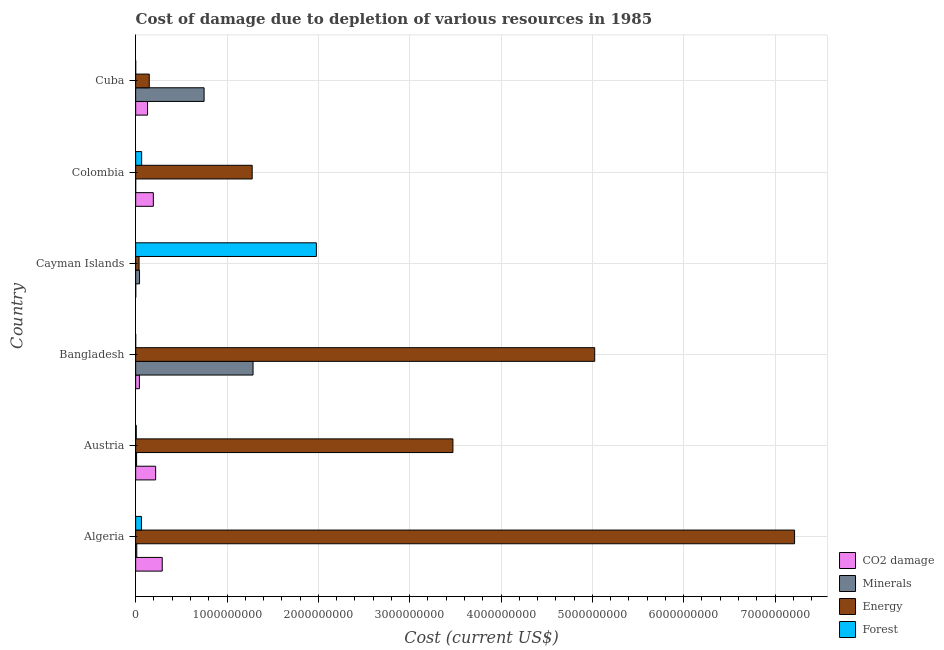Are the number of bars on each tick of the Y-axis equal?
Provide a succinct answer. Yes. How many bars are there on the 6th tick from the top?
Your response must be concise. 4. How many bars are there on the 4th tick from the bottom?
Provide a short and direct response. 4. What is the label of the 2nd group of bars from the top?
Your response must be concise. Colombia. What is the cost of damage due to depletion of coal in Cuba?
Make the answer very short. 1.30e+08. Across all countries, what is the maximum cost of damage due to depletion of coal?
Provide a short and direct response. 2.91e+08. Across all countries, what is the minimum cost of damage due to depletion of energy?
Keep it short and to the point. 3.70e+07. In which country was the cost of damage due to depletion of coal maximum?
Keep it short and to the point. Algeria. In which country was the cost of damage due to depletion of energy minimum?
Ensure brevity in your answer.  Cayman Islands. What is the total cost of damage due to depletion of forests in the graph?
Make the answer very short. 2.11e+09. What is the difference between the cost of damage due to depletion of minerals in Austria and that in Bangladesh?
Offer a terse response. -1.27e+09. What is the difference between the cost of damage due to depletion of forests in Bangladesh and the cost of damage due to depletion of coal in Cuba?
Give a very brief answer. -1.30e+08. What is the average cost of damage due to depletion of energy per country?
Ensure brevity in your answer.  2.86e+09. What is the difference between the cost of damage due to depletion of coal and cost of damage due to depletion of energy in Algeria?
Your answer should be very brief. -6.92e+09. In how many countries, is the cost of damage due to depletion of minerals greater than 5200000000 US$?
Give a very brief answer. 0. What is the ratio of the cost of damage due to depletion of forests in Algeria to that in Cayman Islands?
Give a very brief answer. 0.03. Is the cost of damage due to depletion of energy in Bangladesh less than that in Cayman Islands?
Keep it short and to the point. No. Is the difference between the cost of damage due to depletion of forests in Algeria and Cuba greater than the difference between the cost of damage due to depletion of coal in Algeria and Cuba?
Keep it short and to the point. No. What is the difference between the highest and the second highest cost of damage due to depletion of coal?
Provide a short and direct response. 7.23e+07. What is the difference between the highest and the lowest cost of damage due to depletion of forests?
Offer a terse response. 1.98e+09. In how many countries, is the cost of damage due to depletion of forests greater than the average cost of damage due to depletion of forests taken over all countries?
Offer a terse response. 1. Is it the case that in every country, the sum of the cost of damage due to depletion of coal and cost of damage due to depletion of forests is greater than the sum of cost of damage due to depletion of minerals and cost of damage due to depletion of energy?
Your response must be concise. No. What does the 4th bar from the top in Bangladesh represents?
Ensure brevity in your answer.  CO2 damage. What does the 2nd bar from the bottom in Cuba represents?
Ensure brevity in your answer.  Minerals. How many bars are there?
Your response must be concise. 24. Are all the bars in the graph horizontal?
Provide a short and direct response. Yes. How many countries are there in the graph?
Offer a terse response. 6. Does the graph contain any zero values?
Offer a very short reply. No. Does the graph contain grids?
Your response must be concise. Yes. Where does the legend appear in the graph?
Your answer should be compact. Bottom right. How many legend labels are there?
Provide a short and direct response. 4. What is the title of the graph?
Keep it short and to the point. Cost of damage due to depletion of various resources in 1985 . Does "Fiscal policy" appear as one of the legend labels in the graph?
Your answer should be compact. No. What is the label or title of the X-axis?
Your response must be concise. Cost (current US$). What is the label or title of the Y-axis?
Your answer should be compact. Country. What is the Cost (current US$) of CO2 damage in Algeria?
Your answer should be compact. 2.91e+08. What is the Cost (current US$) of Minerals in Algeria?
Your answer should be very brief. 1.20e+07. What is the Cost (current US$) in Energy in Algeria?
Provide a succinct answer. 7.21e+09. What is the Cost (current US$) in Forest in Algeria?
Make the answer very short. 6.32e+07. What is the Cost (current US$) of CO2 damage in Austria?
Give a very brief answer. 2.19e+08. What is the Cost (current US$) of Minerals in Austria?
Provide a short and direct response. 1.01e+07. What is the Cost (current US$) in Energy in Austria?
Offer a very short reply. 3.47e+09. What is the Cost (current US$) in Forest in Austria?
Provide a short and direct response. 6.24e+06. What is the Cost (current US$) in CO2 damage in Bangladesh?
Ensure brevity in your answer.  4.09e+07. What is the Cost (current US$) in Minerals in Bangladesh?
Keep it short and to the point. 1.29e+09. What is the Cost (current US$) of Energy in Bangladesh?
Your answer should be compact. 5.03e+09. What is the Cost (current US$) in Forest in Bangladesh?
Your answer should be compact. 6.86e+04. What is the Cost (current US$) in CO2 damage in Cayman Islands?
Give a very brief answer. 7.77e+05. What is the Cost (current US$) of Minerals in Cayman Islands?
Provide a succinct answer. 4.23e+07. What is the Cost (current US$) of Energy in Cayman Islands?
Offer a very short reply. 3.70e+07. What is the Cost (current US$) of Forest in Cayman Islands?
Your answer should be very brief. 1.98e+09. What is the Cost (current US$) of CO2 damage in Colombia?
Give a very brief answer. 1.93e+08. What is the Cost (current US$) in Minerals in Colombia?
Your answer should be compact. 9103.63. What is the Cost (current US$) of Energy in Colombia?
Offer a very short reply. 1.28e+09. What is the Cost (current US$) in Forest in Colombia?
Provide a succinct answer. 6.54e+07. What is the Cost (current US$) in CO2 damage in Cuba?
Give a very brief answer. 1.30e+08. What is the Cost (current US$) in Minerals in Cuba?
Make the answer very short. 7.49e+08. What is the Cost (current US$) in Energy in Cuba?
Your answer should be very brief. 1.49e+08. What is the Cost (current US$) of Forest in Cuba?
Your answer should be compact. 6.25e+04. Across all countries, what is the maximum Cost (current US$) in CO2 damage?
Provide a succinct answer. 2.91e+08. Across all countries, what is the maximum Cost (current US$) of Minerals?
Offer a very short reply. 1.29e+09. Across all countries, what is the maximum Cost (current US$) of Energy?
Ensure brevity in your answer.  7.21e+09. Across all countries, what is the maximum Cost (current US$) of Forest?
Provide a succinct answer. 1.98e+09. Across all countries, what is the minimum Cost (current US$) in CO2 damage?
Your answer should be very brief. 7.77e+05. Across all countries, what is the minimum Cost (current US$) in Minerals?
Your response must be concise. 9103.63. Across all countries, what is the minimum Cost (current US$) in Energy?
Offer a terse response. 3.70e+07. Across all countries, what is the minimum Cost (current US$) of Forest?
Provide a short and direct response. 6.25e+04. What is the total Cost (current US$) of CO2 damage in the graph?
Ensure brevity in your answer.  8.75e+08. What is the total Cost (current US$) of Minerals in the graph?
Offer a very short reply. 2.10e+09. What is the total Cost (current US$) of Energy in the graph?
Offer a very short reply. 1.72e+1. What is the total Cost (current US$) of Forest in the graph?
Offer a very short reply. 2.11e+09. What is the difference between the Cost (current US$) of CO2 damage in Algeria and that in Austria?
Your answer should be very brief. 7.23e+07. What is the difference between the Cost (current US$) in Minerals in Algeria and that in Austria?
Offer a terse response. 1.90e+06. What is the difference between the Cost (current US$) in Energy in Algeria and that in Austria?
Your answer should be compact. 3.74e+09. What is the difference between the Cost (current US$) in Forest in Algeria and that in Austria?
Offer a very short reply. 5.70e+07. What is the difference between the Cost (current US$) of CO2 damage in Algeria and that in Bangladesh?
Your answer should be compact. 2.50e+08. What is the difference between the Cost (current US$) of Minerals in Algeria and that in Bangladesh?
Your answer should be compact. -1.27e+09. What is the difference between the Cost (current US$) in Energy in Algeria and that in Bangladesh?
Offer a very short reply. 2.19e+09. What is the difference between the Cost (current US$) in Forest in Algeria and that in Bangladesh?
Give a very brief answer. 6.32e+07. What is the difference between the Cost (current US$) in CO2 damage in Algeria and that in Cayman Islands?
Your answer should be very brief. 2.90e+08. What is the difference between the Cost (current US$) in Minerals in Algeria and that in Cayman Islands?
Provide a short and direct response. -3.03e+07. What is the difference between the Cost (current US$) in Energy in Algeria and that in Cayman Islands?
Your answer should be very brief. 7.18e+09. What is the difference between the Cost (current US$) in Forest in Algeria and that in Cayman Islands?
Your response must be concise. -1.92e+09. What is the difference between the Cost (current US$) of CO2 damage in Algeria and that in Colombia?
Your answer should be compact. 9.75e+07. What is the difference between the Cost (current US$) of Minerals in Algeria and that in Colombia?
Your answer should be very brief. 1.20e+07. What is the difference between the Cost (current US$) in Energy in Algeria and that in Colombia?
Provide a succinct answer. 5.94e+09. What is the difference between the Cost (current US$) of Forest in Algeria and that in Colombia?
Provide a short and direct response. -2.21e+06. What is the difference between the Cost (current US$) in CO2 damage in Algeria and that in Cuba?
Your answer should be very brief. 1.61e+08. What is the difference between the Cost (current US$) of Minerals in Algeria and that in Cuba?
Offer a terse response. -7.37e+08. What is the difference between the Cost (current US$) of Energy in Algeria and that in Cuba?
Offer a very short reply. 7.07e+09. What is the difference between the Cost (current US$) in Forest in Algeria and that in Cuba?
Give a very brief answer. 6.32e+07. What is the difference between the Cost (current US$) of CO2 damage in Austria and that in Bangladesh?
Keep it short and to the point. 1.78e+08. What is the difference between the Cost (current US$) in Minerals in Austria and that in Bangladesh?
Keep it short and to the point. -1.27e+09. What is the difference between the Cost (current US$) in Energy in Austria and that in Bangladesh?
Give a very brief answer. -1.55e+09. What is the difference between the Cost (current US$) in Forest in Austria and that in Bangladesh?
Your answer should be compact. 6.17e+06. What is the difference between the Cost (current US$) of CO2 damage in Austria and that in Cayman Islands?
Offer a very short reply. 2.18e+08. What is the difference between the Cost (current US$) in Minerals in Austria and that in Cayman Islands?
Make the answer very short. -3.22e+07. What is the difference between the Cost (current US$) in Energy in Austria and that in Cayman Islands?
Your answer should be compact. 3.44e+09. What is the difference between the Cost (current US$) in Forest in Austria and that in Cayman Islands?
Provide a succinct answer. -1.97e+09. What is the difference between the Cost (current US$) of CO2 damage in Austria and that in Colombia?
Your response must be concise. 2.53e+07. What is the difference between the Cost (current US$) of Minerals in Austria and that in Colombia?
Ensure brevity in your answer.  1.01e+07. What is the difference between the Cost (current US$) in Energy in Austria and that in Colombia?
Offer a very short reply. 2.20e+09. What is the difference between the Cost (current US$) of Forest in Austria and that in Colombia?
Provide a short and direct response. -5.92e+07. What is the difference between the Cost (current US$) of CO2 damage in Austria and that in Cuba?
Give a very brief answer. 8.84e+07. What is the difference between the Cost (current US$) of Minerals in Austria and that in Cuba?
Give a very brief answer. -7.39e+08. What is the difference between the Cost (current US$) in Energy in Austria and that in Cuba?
Your answer should be very brief. 3.32e+09. What is the difference between the Cost (current US$) of Forest in Austria and that in Cuba?
Offer a very short reply. 6.18e+06. What is the difference between the Cost (current US$) of CO2 damage in Bangladesh and that in Cayman Islands?
Your response must be concise. 4.01e+07. What is the difference between the Cost (current US$) in Minerals in Bangladesh and that in Cayman Islands?
Your answer should be compact. 1.24e+09. What is the difference between the Cost (current US$) of Energy in Bangladesh and that in Cayman Islands?
Make the answer very short. 4.99e+09. What is the difference between the Cost (current US$) of Forest in Bangladesh and that in Cayman Islands?
Ensure brevity in your answer.  -1.98e+09. What is the difference between the Cost (current US$) of CO2 damage in Bangladesh and that in Colombia?
Your response must be concise. -1.52e+08. What is the difference between the Cost (current US$) of Minerals in Bangladesh and that in Colombia?
Your answer should be very brief. 1.29e+09. What is the difference between the Cost (current US$) in Energy in Bangladesh and that in Colombia?
Make the answer very short. 3.75e+09. What is the difference between the Cost (current US$) of Forest in Bangladesh and that in Colombia?
Provide a succinct answer. -6.54e+07. What is the difference between the Cost (current US$) of CO2 damage in Bangladesh and that in Cuba?
Keep it short and to the point. -8.93e+07. What is the difference between the Cost (current US$) in Minerals in Bangladesh and that in Cuba?
Provide a succinct answer. 5.36e+08. What is the difference between the Cost (current US$) in Energy in Bangladesh and that in Cuba?
Keep it short and to the point. 4.88e+09. What is the difference between the Cost (current US$) in Forest in Bangladesh and that in Cuba?
Your answer should be very brief. 6110.87. What is the difference between the Cost (current US$) in CO2 damage in Cayman Islands and that in Colombia?
Give a very brief answer. -1.93e+08. What is the difference between the Cost (current US$) of Minerals in Cayman Islands and that in Colombia?
Your answer should be compact. 4.23e+07. What is the difference between the Cost (current US$) of Energy in Cayman Islands and that in Colombia?
Your answer should be very brief. -1.24e+09. What is the difference between the Cost (current US$) in Forest in Cayman Islands and that in Colombia?
Provide a short and direct response. 1.91e+09. What is the difference between the Cost (current US$) of CO2 damage in Cayman Islands and that in Cuba?
Make the answer very short. -1.29e+08. What is the difference between the Cost (current US$) in Minerals in Cayman Islands and that in Cuba?
Ensure brevity in your answer.  -7.07e+08. What is the difference between the Cost (current US$) of Energy in Cayman Islands and that in Cuba?
Your response must be concise. -1.12e+08. What is the difference between the Cost (current US$) in Forest in Cayman Islands and that in Cuba?
Keep it short and to the point. 1.98e+09. What is the difference between the Cost (current US$) in CO2 damage in Colombia and that in Cuba?
Ensure brevity in your answer.  6.31e+07. What is the difference between the Cost (current US$) in Minerals in Colombia and that in Cuba?
Provide a short and direct response. -7.49e+08. What is the difference between the Cost (current US$) of Energy in Colombia and that in Cuba?
Offer a terse response. 1.13e+09. What is the difference between the Cost (current US$) of Forest in Colombia and that in Cuba?
Give a very brief answer. 6.54e+07. What is the difference between the Cost (current US$) in CO2 damage in Algeria and the Cost (current US$) in Minerals in Austria?
Offer a very short reply. 2.81e+08. What is the difference between the Cost (current US$) in CO2 damage in Algeria and the Cost (current US$) in Energy in Austria?
Give a very brief answer. -3.18e+09. What is the difference between the Cost (current US$) of CO2 damage in Algeria and the Cost (current US$) of Forest in Austria?
Offer a terse response. 2.85e+08. What is the difference between the Cost (current US$) of Minerals in Algeria and the Cost (current US$) of Energy in Austria?
Ensure brevity in your answer.  -3.46e+09. What is the difference between the Cost (current US$) of Minerals in Algeria and the Cost (current US$) of Forest in Austria?
Make the answer very short. 5.74e+06. What is the difference between the Cost (current US$) of Energy in Algeria and the Cost (current US$) of Forest in Austria?
Provide a succinct answer. 7.21e+09. What is the difference between the Cost (current US$) in CO2 damage in Algeria and the Cost (current US$) in Minerals in Bangladesh?
Offer a terse response. -9.94e+08. What is the difference between the Cost (current US$) in CO2 damage in Algeria and the Cost (current US$) in Energy in Bangladesh?
Offer a terse response. -4.73e+09. What is the difference between the Cost (current US$) of CO2 damage in Algeria and the Cost (current US$) of Forest in Bangladesh?
Provide a succinct answer. 2.91e+08. What is the difference between the Cost (current US$) in Minerals in Algeria and the Cost (current US$) in Energy in Bangladesh?
Give a very brief answer. -5.01e+09. What is the difference between the Cost (current US$) of Minerals in Algeria and the Cost (current US$) of Forest in Bangladesh?
Your answer should be compact. 1.19e+07. What is the difference between the Cost (current US$) of Energy in Algeria and the Cost (current US$) of Forest in Bangladesh?
Your answer should be compact. 7.21e+09. What is the difference between the Cost (current US$) in CO2 damage in Algeria and the Cost (current US$) in Minerals in Cayman Islands?
Offer a terse response. 2.49e+08. What is the difference between the Cost (current US$) of CO2 damage in Algeria and the Cost (current US$) of Energy in Cayman Islands?
Your answer should be compact. 2.54e+08. What is the difference between the Cost (current US$) in CO2 damage in Algeria and the Cost (current US$) in Forest in Cayman Islands?
Give a very brief answer. -1.69e+09. What is the difference between the Cost (current US$) of Minerals in Algeria and the Cost (current US$) of Energy in Cayman Islands?
Make the answer very short. -2.51e+07. What is the difference between the Cost (current US$) in Minerals in Algeria and the Cost (current US$) in Forest in Cayman Islands?
Give a very brief answer. -1.97e+09. What is the difference between the Cost (current US$) in Energy in Algeria and the Cost (current US$) in Forest in Cayman Islands?
Keep it short and to the point. 5.24e+09. What is the difference between the Cost (current US$) in CO2 damage in Algeria and the Cost (current US$) in Minerals in Colombia?
Your answer should be compact. 2.91e+08. What is the difference between the Cost (current US$) in CO2 damage in Algeria and the Cost (current US$) in Energy in Colombia?
Provide a short and direct response. -9.85e+08. What is the difference between the Cost (current US$) of CO2 damage in Algeria and the Cost (current US$) of Forest in Colombia?
Your answer should be very brief. 2.25e+08. What is the difference between the Cost (current US$) of Minerals in Algeria and the Cost (current US$) of Energy in Colombia?
Ensure brevity in your answer.  -1.26e+09. What is the difference between the Cost (current US$) in Minerals in Algeria and the Cost (current US$) in Forest in Colombia?
Offer a very short reply. -5.35e+07. What is the difference between the Cost (current US$) in Energy in Algeria and the Cost (current US$) in Forest in Colombia?
Keep it short and to the point. 7.15e+09. What is the difference between the Cost (current US$) of CO2 damage in Algeria and the Cost (current US$) of Minerals in Cuba?
Keep it short and to the point. -4.58e+08. What is the difference between the Cost (current US$) in CO2 damage in Algeria and the Cost (current US$) in Energy in Cuba?
Provide a short and direct response. 1.42e+08. What is the difference between the Cost (current US$) of CO2 damage in Algeria and the Cost (current US$) of Forest in Cuba?
Give a very brief answer. 2.91e+08. What is the difference between the Cost (current US$) of Minerals in Algeria and the Cost (current US$) of Energy in Cuba?
Make the answer very short. -1.37e+08. What is the difference between the Cost (current US$) of Minerals in Algeria and the Cost (current US$) of Forest in Cuba?
Make the answer very short. 1.19e+07. What is the difference between the Cost (current US$) of Energy in Algeria and the Cost (current US$) of Forest in Cuba?
Ensure brevity in your answer.  7.21e+09. What is the difference between the Cost (current US$) in CO2 damage in Austria and the Cost (current US$) in Minerals in Bangladesh?
Your answer should be compact. -1.07e+09. What is the difference between the Cost (current US$) of CO2 damage in Austria and the Cost (current US$) of Energy in Bangladesh?
Your answer should be very brief. -4.81e+09. What is the difference between the Cost (current US$) of CO2 damage in Austria and the Cost (current US$) of Forest in Bangladesh?
Make the answer very short. 2.18e+08. What is the difference between the Cost (current US$) of Minerals in Austria and the Cost (current US$) of Energy in Bangladesh?
Your answer should be very brief. -5.02e+09. What is the difference between the Cost (current US$) of Minerals in Austria and the Cost (current US$) of Forest in Bangladesh?
Ensure brevity in your answer.  1.00e+07. What is the difference between the Cost (current US$) of Energy in Austria and the Cost (current US$) of Forest in Bangladesh?
Offer a very short reply. 3.47e+09. What is the difference between the Cost (current US$) in CO2 damage in Austria and the Cost (current US$) in Minerals in Cayman Islands?
Your answer should be compact. 1.76e+08. What is the difference between the Cost (current US$) of CO2 damage in Austria and the Cost (current US$) of Energy in Cayman Islands?
Ensure brevity in your answer.  1.82e+08. What is the difference between the Cost (current US$) of CO2 damage in Austria and the Cost (current US$) of Forest in Cayman Islands?
Your answer should be compact. -1.76e+09. What is the difference between the Cost (current US$) in Minerals in Austria and the Cost (current US$) in Energy in Cayman Islands?
Make the answer very short. -2.70e+07. What is the difference between the Cost (current US$) in Minerals in Austria and the Cost (current US$) in Forest in Cayman Islands?
Keep it short and to the point. -1.97e+09. What is the difference between the Cost (current US$) of Energy in Austria and the Cost (current US$) of Forest in Cayman Islands?
Your answer should be compact. 1.49e+09. What is the difference between the Cost (current US$) of CO2 damage in Austria and the Cost (current US$) of Minerals in Colombia?
Give a very brief answer. 2.19e+08. What is the difference between the Cost (current US$) of CO2 damage in Austria and the Cost (current US$) of Energy in Colombia?
Offer a terse response. -1.06e+09. What is the difference between the Cost (current US$) in CO2 damage in Austria and the Cost (current US$) in Forest in Colombia?
Your answer should be very brief. 1.53e+08. What is the difference between the Cost (current US$) in Minerals in Austria and the Cost (current US$) in Energy in Colombia?
Give a very brief answer. -1.27e+09. What is the difference between the Cost (current US$) of Minerals in Austria and the Cost (current US$) of Forest in Colombia?
Keep it short and to the point. -5.54e+07. What is the difference between the Cost (current US$) in Energy in Austria and the Cost (current US$) in Forest in Colombia?
Offer a terse response. 3.41e+09. What is the difference between the Cost (current US$) in CO2 damage in Austria and the Cost (current US$) in Minerals in Cuba?
Offer a terse response. -5.31e+08. What is the difference between the Cost (current US$) in CO2 damage in Austria and the Cost (current US$) in Energy in Cuba?
Ensure brevity in your answer.  6.97e+07. What is the difference between the Cost (current US$) of CO2 damage in Austria and the Cost (current US$) of Forest in Cuba?
Your response must be concise. 2.18e+08. What is the difference between the Cost (current US$) of Minerals in Austria and the Cost (current US$) of Energy in Cuba?
Give a very brief answer. -1.39e+08. What is the difference between the Cost (current US$) of Minerals in Austria and the Cost (current US$) of Forest in Cuba?
Your answer should be very brief. 1.00e+07. What is the difference between the Cost (current US$) of Energy in Austria and the Cost (current US$) of Forest in Cuba?
Your answer should be very brief. 3.47e+09. What is the difference between the Cost (current US$) in CO2 damage in Bangladesh and the Cost (current US$) in Minerals in Cayman Islands?
Provide a succinct answer. -1.40e+06. What is the difference between the Cost (current US$) in CO2 damage in Bangladesh and the Cost (current US$) in Energy in Cayman Islands?
Provide a short and direct response. 3.86e+06. What is the difference between the Cost (current US$) in CO2 damage in Bangladesh and the Cost (current US$) in Forest in Cayman Islands?
Keep it short and to the point. -1.94e+09. What is the difference between the Cost (current US$) in Minerals in Bangladesh and the Cost (current US$) in Energy in Cayman Islands?
Keep it short and to the point. 1.25e+09. What is the difference between the Cost (current US$) of Minerals in Bangladesh and the Cost (current US$) of Forest in Cayman Islands?
Provide a succinct answer. -6.93e+08. What is the difference between the Cost (current US$) of Energy in Bangladesh and the Cost (current US$) of Forest in Cayman Islands?
Make the answer very short. 3.05e+09. What is the difference between the Cost (current US$) of CO2 damage in Bangladesh and the Cost (current US$) of Minerals in Colombia?
Keep it short and to the point. 4.09e+07. What is the difference between the Cost (current US$) of CO2 damage in Bangladesh and the Cost (current US$) of Energy in Colombia?
Make the answer very short. -1.23e+09. What is the difference between the Cost (current US$) of CO2 damage in Bangladesh and the Cost (current US$) of Forest in Colombia?
Keep it short and to the point. -2.45e+07. What is the difference between the Cost (current US$) of Minerals in Bangladesh and the Cost (current US$) of Energy in Colombia?
Offer a terse response. 9.38e+06. What is the difference between the Cost (current US$) of Minerals in Bangladesh and the Cost (current US$) of Forest in Colombia?
Provide a succinct answer. 1.22e+09. What is the difference between the Cost (current US$) of Energy in Bangladesh and the Cost (current US$) of Forest in Colombia?
Your answer should be compact. 4.96e+09. What is the difference between the Cost (current US$) in CO2 damage in Bangladesh and the Cost (current US$) in Minerals in Cuba?
Provide a short and direct response. -7.08e+08. What is the difference between the Cost (current US$) of CO2 damage in Bangladesh and the Cost (current US$) of Energy in Cuba?
Provide a succinct answer. -1.08e+08. What is the difference between the Cost (current US$) in CO2 damage in Bangladesh and the Cost (current US$) in Forest in Cuba?
Your answer should be compact. 4.08e+07. What is the difference between the Cost (current US$) in Minerals in Bangladesh and the Cost (current US$) in Energy in Cuba?
Give a very brief answer. 1.14e+09. What is the difference between the Cost (current US$) of Minerals in Bangladesh and the Cost (current US$) of Forest in Cuba?
Give a very brief answer. 1.28e+09. What is the difference between the Cost (current US$) in Energy in Bangladesh and the Cost (current US$) in Forest in Cuba?
Your answer should be very brief. 5.03e+09. What is the difference between the Cost (current US$) of CO2 damage in Cayman Islands and the Cost (current US$) of Minerals in Colombia?
Your answer should be compact. 7.67e+05. What is the difference between the Cost (current US$) in CO2 damage in Cayman Islands and the Cost (current US$) in Energy in Colombia?
Provide a succinct answer. -1.27e+09. What is the difference between the Cost (current US$) in CO2 damage in Cayman Islands and the Cost (current US$) in Forest in Colombia?
Offer a terse response. -6.47e+07. What is the difference between the Cost (current US$) in Minerals in Cayman Islands and the Cost (current US$) in Energy in Colombia?
Provide a succinct answer. -1.23e+09. What is the difference between the Cost (current US$) of Minerals in Cayman Islands and the Cost (current US$) of Forest in Colombia?
Provide a succinct answer. -2.31e+07. What is the difference between the Cost (current US$) in Energy in Cayman Islands and the Cost (current US$) in Forest in Colombia?
Provide a succinct answer. -2.84e+07. What is the difference between the Cost (current US$) in CO2 damage in Cayman Islands and the Cost (current US$) in Minerals in Cuba?
Your answer should be very brief. -7.48e+08. What is the difference between the Cost (current US$) in CO2 damage in Cayman Islands and the Cost (current US$) in Energy in Cuba?
Make the answer very short. -1.48e+08. What is the difference between the Cost (current US$) in CO2 damage in Cayman Islands and the Cost (current US$) in Forest in Cuba?
Your answer should be very brief. 7.14e+05. What is the difference between the Cost (current US$) of Minerals in Cayman Islands and the Cost (current US$) of Energy in Cuba?
Your answer should be very brief. -1.07e+08. What is the difference between the Cost (current US$) of Minerals in Cayman Islands and the Cost (current US$) of Forest in Cuba?
Your answer should be compact. 4.22e+07. What is the difference between the Cost (current US$) of Energy in Cayman Islands and the Cost (current US$) of Forest in Cuba?
Offer a very short reply. 3.70e+07. What is the difference between the Cost (current US$) of CO2 damage in Colombia and the Cost (current US$) of Minerals in Cuba?
Offer a terse response. -5.56e+08. What is the difference between the Cost (current US$) of CO2 damage in Colombia and the Cost (current US$) of Energy in Cuba?
Your answer should be very brief. 4.45e+07. What is the difference between the Cost (current US$) of CO2 damage in Colombia and the Cost (current US$) of Forest in Cuba?
Provide a short and direct response. 1.93e+08. What is the difference between the Cost (current US$) of Minerals in Colombia and the Cost (current US$) of Energy in Cuba?
Your answer should be compact. -1.49e+08. What is the difference between the Cost (current US$) of Minerals in Colombia and the Cost (current US$) of Forest in Cuba?
Your response must be concise. -5.34e+04. What is the difference between the Cost (current US$) of Energy in Colombia and the Cost (current US$) of Forest in Cuba?
Provide a short and direct response. 1.28e+09. What is the average Cost (current US$) in CO2 damage per country?
Your answer should be compact. 1.46e+08. What is the average Cost (current US$) in Minerals per country?
Offer a very short reply. 3.50e+08. What is the average Cost (current US$) in Energy per country?
Make the answer very short. 2.86e+09. What is the average Cost (current US$) of Forest per country?
Your answer should be compact. 3.52e+08. What is the difference between the Cost (current US$) in CO2 damage and Cost (current US$) in Minerals in Algeria?
Offer a very short reply. 2.79e+08. What is the difference between the Cost (current US$) in CO2 damage and Cost (current US$) in Energy in Algeria?
Provide a short and direct response. -6.92e+09. What is the difference between the Cost (current US$) of CO2 damage and Cost (current US$) of Forest in Algeria?
Give a very brief answer. 2.28e+08. What is the difference between the Cost (current US$) of Minerals and Cost (current US$) of Energy in Algeria?
Ensure brevity in your answer.  -7.20e+09. What is the difference between the Cost (current US$) in Minerals and Cost (current US$) in Forest in Algeria?
Give a very brief answer. -5.12e+07. What is the difference between the Cost (current US$) of Energy and Cost (current US$) of Forest in Algeria?
Ensure brevity in your answer.  7.15e+09. What is the difference between the Cost (current US$) of CO2 damage and Cost (current US$) of Minerals in Austria?
Offer a terse response. 2.08e+08. What is the difference between the Cost (current US$) in CO2 damage and Cost (current US$) in Energy in Austria?
Your answer should be compact. -3.25e+09. What is the difference between the Cost (current US$) in CO2 damage and Cost (current US$) in Forest in Austria?
Offer a very short reply. 2.12e+08. What is the difference between the Cost (current US$) in Minerals and Cost (current US$) in Energy in Austria?
Provide a short and direct response. -3.46e+09. What is the difference between the Cost (current US$) in Minerals and Cost (current US$) in Forest in Austria?
Make the answer very short. 3.84e+06. What is the difference between the Cost (current US$) of Energy and Cost (current US$) of Forest in Austria?
Offer a very short reply. 3.47e+09. What is the difference between the Cost (current US$) of CO2 damage and Cost (current US$) of Minerals in Bangladesh?
Your answer should be very brief. -1.24e+09. What is the difference between the Cost (current US$) of CO2 damage and Cost (current US$) of Energy in Bangladesh?
Give a very brief answer. -4.98e+09. What is the difference between the Cost (current US$) of CO2 damage and Cost (current US$) of Forest in Bangladesh?
Offer a terse response. 4.08e+07. What is the difference between the Cost (current US$) of Minerals and Cost (current US$) of Energy in Bangladesh?
Provide a short and direct response. -3.74e+09. What is the difference between the Cost (current US$) of Minerals and Cost (current US$) of Forest in Bangladesh?
Give a very brief answer. 1.28e+09. What is the difference between the Cost (current US$) in Energy and Cost (current US$) in Forest in Bangladesh?
Offer a very short reply. 5.03e+09. What is the difference between the Cost (current US$) of CO2 damage and Cost (current US$) of Minerals in Cayman Islands?
Offer a terse response. -4.15e+07. What is the difference between the Cost (current US$) in CO2 damage and Cost (current US$) in Energy in Cayman Islands?
Provide a short and direct response. -3.63e+07. What is the difference between the Cost (current US$) in CO2 damage and Cost (current US$) in Forest in Cayman Islands?
Provide a short and direct response. -1.98e+09. What is the difference between the Cost (current US$) of Minerals and Cost (current US$) of Energy in Cayman Islands?
Your answer should be very brief. 5.26e+06. What is the difference between the Cost (current US$) in Minerals and Cost (current US$) in Forest in Cayman Islands?
Give a very brief answer. -1.94e+09. What is the difference between the Cost (current US$) of Energy and Cost (current US$) of Forest in Cayman Islands?
Offer a very short reply. -1.94e+09. What is the difference between the Cost (current US$) in CO2 damage and Cost (current US$) in Minerals in Colombia?
Offer a terse response. 1.93e+08. What is the difference between the Cost (current US$) in CO2 damage and Cost (current US$) in Energy in Colombia?
Ensure brevity in your answer.  -1.08e+09. What is the difference between the Cost (current US$) of CO2 damage and Cost (current US$) of Forest in Colombia?
Provide a succinct answer. 1.28e+08. What is the difference between the Cost (current US$) of Minerals and Cost (current US$) of Energy in Colombia?
Your response must be concise. -1.28e+09. What is the difference between the Cost (current US$) of Minerals and Cost (current US$) of Forest in Colombia?
Your answer should be very brief. -6.54e+07. What is the difference between the Cost (current US$) in Energy and Cost (current US$) in Forest in Colombia?
Your response must be concise. 1.21e+09. What is the difference between the Cost (current US$) in CO2 damage and Cost (current US$) in Minerals in Cuba?
Give a very brief answer. -6.19e+08. What is the difference between the Cost (current US$) of CO2 damage and Cost (current US$) of Energy in Cuba?
Your answer should be very brief. -1.87e+07. What is the difference between the Cost (current US$) in CO2 damage and Cost (current US$) in Forest in Cuba?
Your answer should be compact. 1.30e+08. What is the difference between the Cost (current US$) in Minerals and Cost (current US$) in Energy in Cuba?
Your answer should be compact. 6.00e+08. What is the difference between the Cost (current US$) in Minerals and Cost (current US$) in Forest in Cuba?
Provide a succinct answer. 7.49e+08. What is the difference between the Cost (current US$) of Energy and Cost (current US$) of Forest in Cuba?
Keep it short and to the point. 1.49e+08. What is the ratio of the Cost (current US$) of CO2 damage in Algeria to that in Austria?
Give a very brief answer. 1.33. What is the ratio of the Cost (current US$) of Minerals in Algeria to that in Austria?
Provide a succinct answer. 1.19. What is the ratio of the Cost (current US$) in Energy in Algeria to that in Austria?
Offer a terse response. 2.08. What is the ratio of the Cost (current US$) of Forest in Algeria to that in Austria?
Offer a very short reply. 10.13. What is the ratio of the Cost (current US$) of CO2 damage in Algeria to that in Bangladesh?
Offer a very short reply. 7.11. What is the ratio of the Cost (current US$) in Minerals in Algeria to that in Bangladesh?
Offer a terse response. 0.01. What is the ratio of the Cost (current US$) of Energy in Algeria to that in Bangladesh?
Ensure brevity in your answer.  1.44. What is the ratio of the Cost (current US$) of Forest in Algeria to that in Bangladesh?
Provide a short and direct response. 921.27. What is the ratio of the Cost (current US$) of CO2 damage in Algeria to that in Cayman Islands?
Your answer should be very brief. 374.51. What is the ratio of the Cost (current US$) in Minerals in Algeria to that in Cayman Islands?
Provide a short and direct response. 0.28. What is the ratio of the Cost (current US$) of Energy in Algeria to that in Cayman Islands?
Give a very brief answer. 194.81. What is the ratio of the Cost (current US$) in Forest in Algeria to that in Cayman Islands?
Your answer should be compact. 0.03. What is the ratio of the Cost (current US$) of CO2 damage in Algeria to that in Colombia?
Give a very brief answer. 1.5. What is the ratio of the Cost (current US$) in Minerals in Algeria to that in Colombia?
Offer a terse response. 1315.95. What is the ratio of the Cost (current US$) of Energy in Algeria to that in Colombia?
Your response must be concise. 5.66. What is the ratio of the Cost (current US$) in Forest in Algeria to that in Colombia?
Provide a succinct answer. 0.97. What is the ratio of the Cost (current US$) of CO2 damage in Algeria to that in Cuba?
Make the answer very short. 2.23. What is the ratio of the Cost (current US$) of Minerals in Algeria to that in Cuba?
Make the answer very short. 0.02. What is the ratio of the Cost (current US$) in Energy in Algeria to that in Cuba?
Your response must be concise. 48.48. What is the ratio of the Cost (current US$) of Forest in Algeria to that in Cuba?
Your answer should be very brief. 1011.33. What is the ratio of the Cost (current US$) of CO2 damage in Austria to that in Bangladesh?
Give a very brief answer. 5.34. What is the ratio of the Cost (current US$) of Minerals in Austria to that in Bangladesh?
Offer a very short reply. 0.01. What is the ratio of the Cost (current US$) of Energy in Austria to that in Bangladesh?
Your response must be concise. 0.69. What is the ratio of the Cost (current US$) in Forest in Austria to that in Bangladesh?
Provide a succinct answer. 90.92. What is the ratio of the Cost (current US$) in CO2 damage in Austria to that in Cayman Islands?
Your answer should be very brief. 281.45. What is the ratio of the Cost (current US$) of Minerals in Austria to that in Cayman Islands?
Provide a short and direct response. 0.24. What is the ratio of the Cost (current US$) of Energy in Austria to that in Cayman Islands?
Offer a terse response. 93.8. What is the ratio of the Cost (current US$) of Forest in Austria to that in Cayman Islands?
Provide a succinct answer. 0. What is the ratio of the Cost (current US$) of CO2 damage in Austria to that in Colombia?
Keep it short and to the point. 1.13. What is the ratio of the Cost (current US$) in Minerals in Austria to that in Colombia?
Ensure brevity in your answer.  1106.77. What is the ratio of the Cost (current US$) of Energy in Austria to that in Colombia?
Your answer should be very brief. 2.72. What is the ratio of the Cost (current US$) in Forest in Austria to that in Colombia?
Your answer should be very brief. 0.1. What is the ratio of the Cost (current US$) of CO2 damage in Austria to that in Cuba?
Provide a succinct answer. 1.68. What is the ratio of the Cost (current US$) in Minerals in Austria to that in Cuba?
Offer a very short reply. 0.01. What is the ratio of the Cost (current US$) in Energy in Austria to that in Cuba?
Your response must be concise. 23.34. What is the ratio of the Cost (current US$) in Forest in Austria to that in Cuba?
Provide a short and direct response. 99.81. What is the ratio of the Cost (current US$) of CO2 damage in Bangladesh to that in Cayman Islands?
Offer a terse response. 52.66. What is the ratio of the Cost (current US$) of Minerals in Bangladesh to that in Cayman Islands?
Provide a succinct answer. 30.39. What is the ratio of the Cost (current US$) in Energy in Bangladesh to that in Cayman Islands?
Your answer should be compact. 135.72. What is the ratio of the Cost (current US$) in CO2 damage in Bangladesh to that in Colombia?
Offer a very short reply. 0.21. What is the ratio of the Cost (current US$) in Minerals in Bangladesh to that in Colombia?
Your answer should be very brief. 1.41e+05. What is the ratio of the Cost (current US$) of Energy in Bangladesh to that in Colombia?
Offer a terse response. 3.94. What is the ratio of the Cost (current US$) in CO2 damage in Bangladesh to that in Cuba?
Keep it short and to the point. 0.31. What is the ratio of the Cost (current US$) in Minerals in Bangladesh to that in Cuba?
Offer a very short reply. 1.72. What is the ratio of the Cost (current US$) of Energy in Bangladesh to that in Cuba?
Provide a succinct answer. 33.77. What is the ratio of the Cost (current US$) of Forest in Bangladesh to that in Cuba?
Offer a terse response. 1.1. What is the ratio of the Cost (current US$) in CO2 damage in Cayman Islands to that in Colombia?
Make the answer very short. 0. What is the ratio of the Cost (current US$) in Minerals in Cayman Islands to that in Colombia?
Offer a terse response. 4645.46. What is the ratio of the Cost (current US$) in Energy in Cayman Islands to that in Colombia?
Your response must be concise. 0.03. What is the ratio of the Cost (current US$) in Forest in Cayman Islands to that in Colombia?
Your answer should be compact. 30.24. What is the ratio of the Cost (current US$) of CO2 damage in Cayman Islands to that in Cuba?
Your response must be concise. 0.01. What is the ratio of the Cost (current US$) in Minerals in Cayman Islands to that in Cuba?
Give a very brief answer. 0.06. What is the ratio of the Cost (current US$) of Energy in Cayman Islands to that in Cuba?
Ensure brevity in your answer.  0.25. What is the ratio of the Cost (current US$) of Forest in Cayman Islands to that in Cuba?
Provide a succinct answer. 3.16e+04. What is the ratio of the Cost (current US$) in CO2 damage in Colombia to that in Cuba?
Ensure brevity in your answer.  1.49. What is the ratio of the Cost (current US$) in Energy in Colombia to that in Cuba?
Your answer should be compact. 8.57. What is the ratio of the Cost (current US$) in Forest in Colombia to that in Cuba?
Your answer should be compact. 1046.67. What is the difference between the highest and the second highest Cost (current US$) of CO2 damage?
Make the answer very short. 7.23e+07. What is the difference between the highest and the second highest Cost (current US$) in Minerals?
Your answer should be compact. 5.36e+08. What is the difference between the highest and the second highest Cost (current US$) in Energy?
Give a very brief answer. 2.19e+09. What is the difference between the highest and the second highest Cost (current US$) in Forest?
Offer a very short reply. 1.91e+09. What is the difference between the highest and the lowest Cost (current US$) of CO2 damage?
Your answer should be very brief. 2.90e+08. What is the difference between the highest and the lowest Cost (current US$) of Minerals?
Your response must be concise. 1.29e+09. What is the difference between the highest and the lowest Cost (current US$) of Energy?
Provide a succinct answer. 7.18e+09. What is the difference between the highest and the lowest Cost (current US$) in Forest?
Provide a succinct answer. 1.98e+09. 